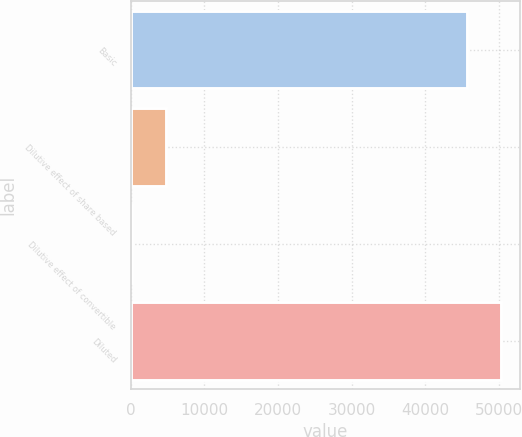<chart> <loc_0><loc_0><loc_500><loc_500><bar_chart><fcel>Basic<fcel>Dilutive effect of share based<fcel>Dilutive effect of convertible<fcel>Diluted<nl><fcel>45689<fcel>4807.9<fcel>142<fcel>50354.9<nl></chart> 